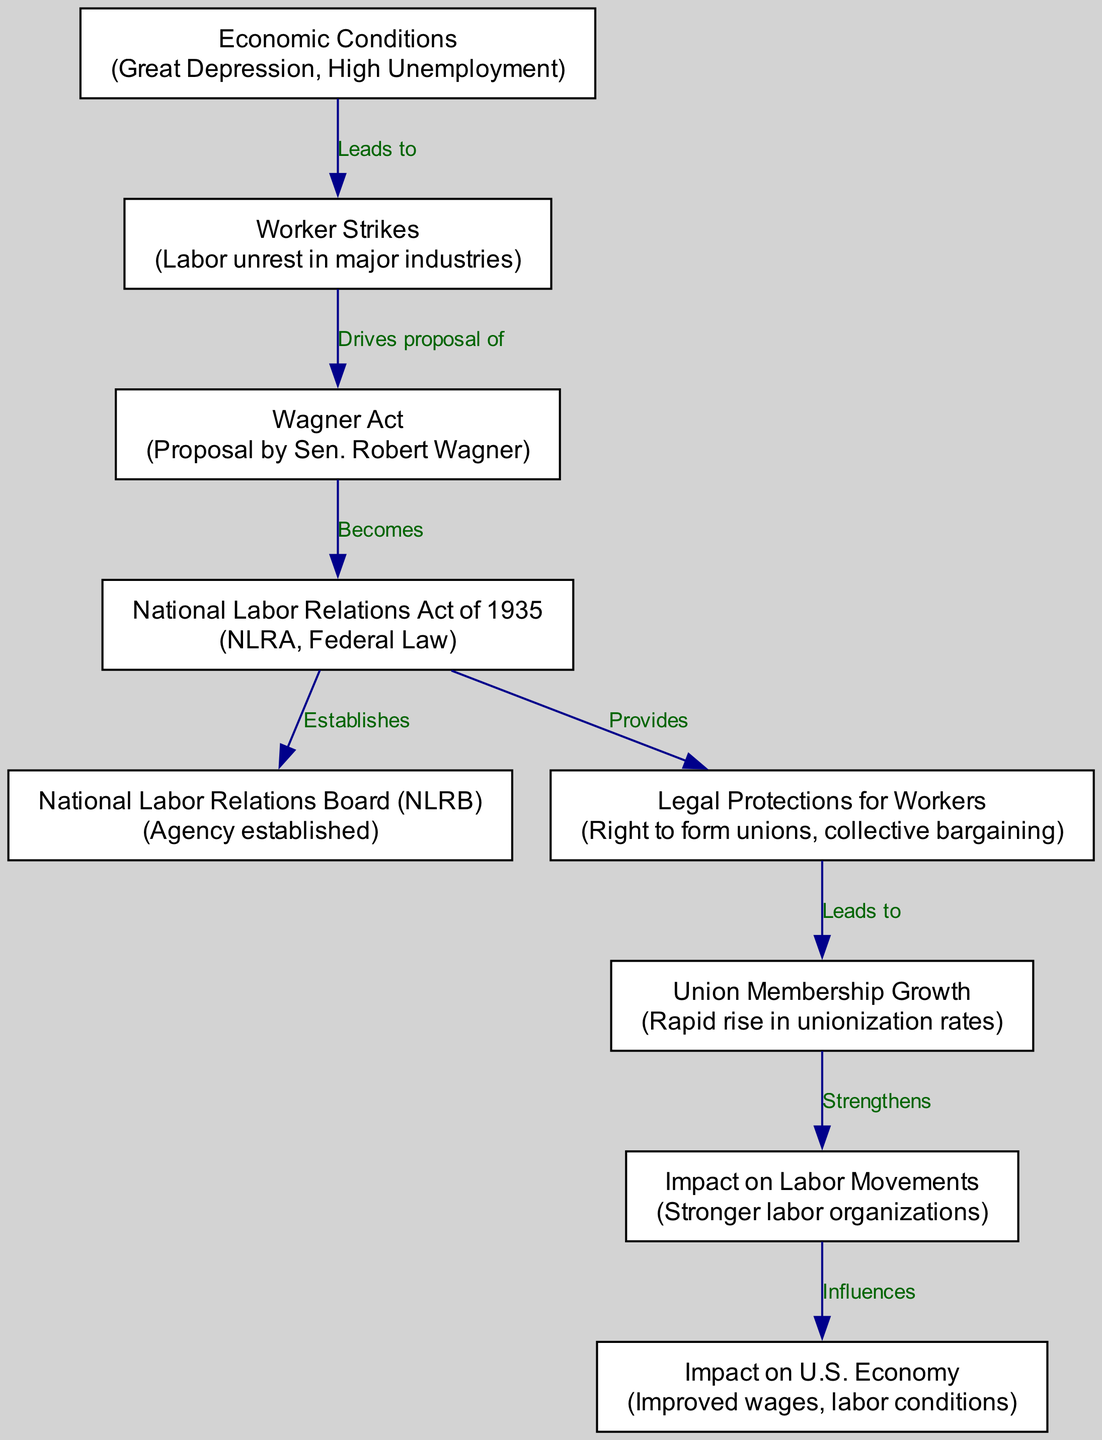What is the first node in the flowchart? The first node is "Economic Conditions," which is shown at the top of the diagram. It serves as the starting point of the flowchart that leads to subsequent nodes.
Answer: Economic Conditions How many nodes are present in the diagram? By counting the listed nodes in the data, we see there are nine nodes that are involved in the flowchart, each representing crucial parts of the labor relations developments.
Answer: 9 What does the National Labor Relations Act of 1935 establish? According to the diagram, the National Labor Relations Act of 1935 establishes the National Labor Relations Board (NLRB), which is a significant outcome of the NLRA.
Answer: National Labor Relations Board (NLRB) What relationship exists between worker strikes and the Wagner Act? The diagram indicates that worker strikes drive the proposal of the Wagner Act. This means the unrest played a critical role in the push for this labor legislation.
Answer: Drives proposal of What is the final impact on the U.S. economy described in the diagram? The last node of the flowchart indicates that the impact on the U.S. economy involves improved wages and labor conditions as a result of stronger labor organizations.
Answer: Improved wages, labor conditions How does legal protection for workers contribute to union growth? The flowchart shows that legal protections for workers lead to union membership growth, suggesting that the rights granted through the NLRA encouraged more workers to join unions.
Answer: Leads to What main factor contributed to the proposal of the Wagner Act? Worker strikes are indicated as the main factor that drives the proposal of the Wagner Act, emphasizing the connection between labor unrest and legislative action.
Answer: Worker Strikes What does the union membership growth influence? According to the flowchart, union membership growth strengthens the impact on labor movements, indicating that increased membership leads to more robust labor organizations.
Answer: Strengthens What did the National Labor Relations Act of 1935 provide to workers? The Act provided legal protections for workers, including the right to form unions and engage in collective bargaining, which is a critical aspect of labor relations.
Answer: Legal Protections for Workers 